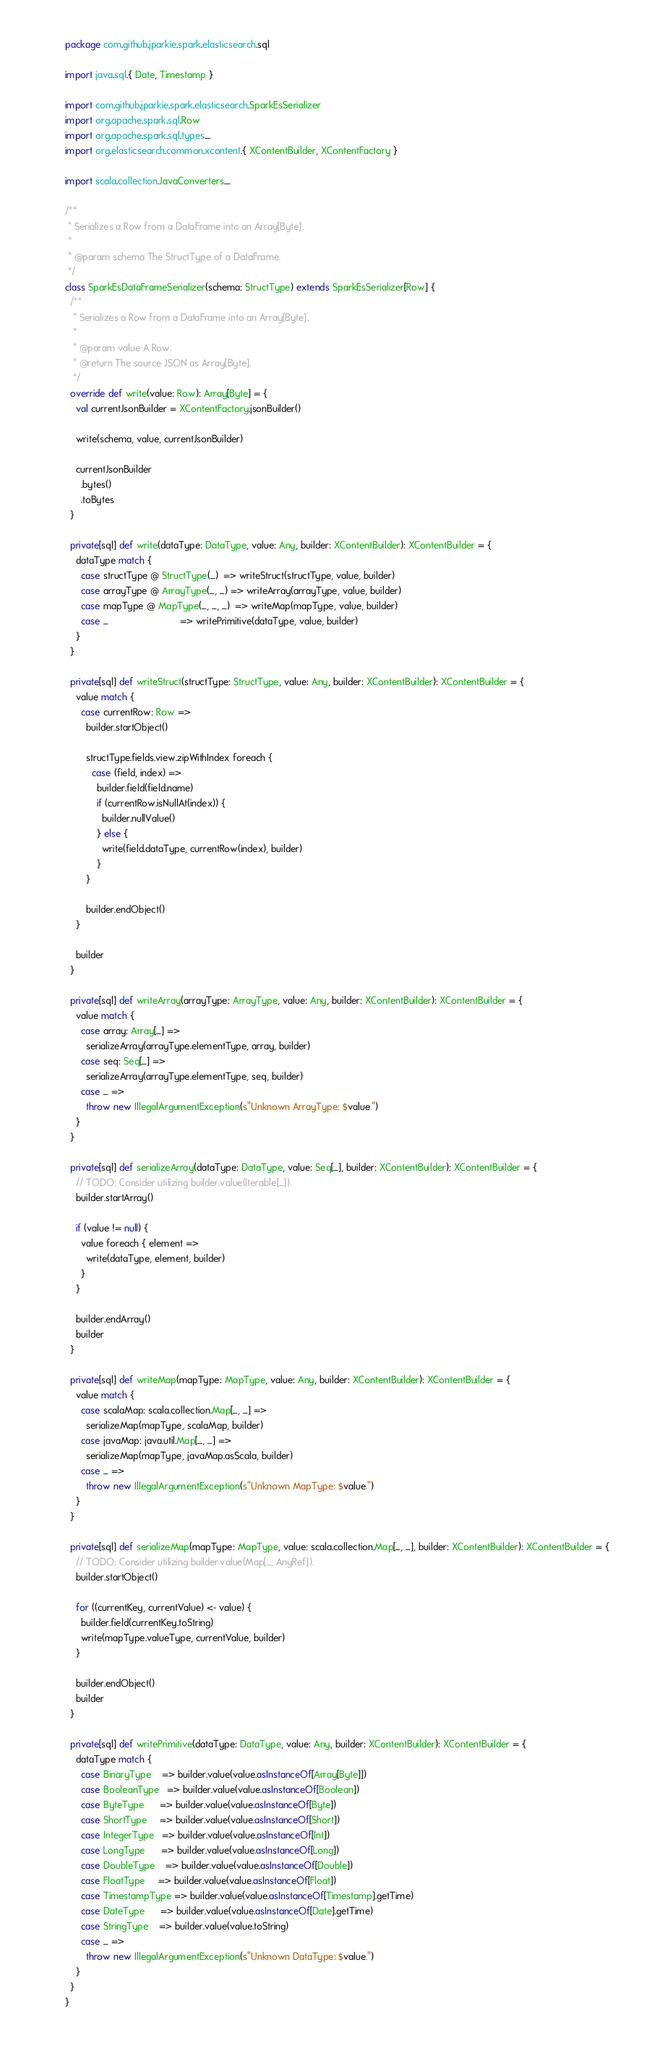Convert code to text. <code><loc_0><loc_0><loc_500><loc_500><_Scala_>package com.github.jparkie.spark.elasticsearch.sql

import java.sql.{ Date, Timestamp }

import com.github.jparkie.spark.elasticsearch.SparkEsSerializer
import org.apache.spark.sql.Row
import org.apache.spark.sql.types._
import org.elasticsearch.common.xcontent.{ XContentBuilder, XContentFactory }

import scala.collection.JavaConverters._

/**
 * Serializes a Row from a DataFrame into an Array[Byte].
 *
 * @param schema The StructType of a DataFrame.
 */
class SparkEsDataFrameSerializer(schema: StructType) extends SparkEsSerializer[Row] {
  /**
   * Serializes a Row from a DataFrame into an Array[Byte].
   *
   * @param value A Row.
   * @return The source JSON as Array[Byte].
   */
  override def write(value: Row): Array[Byte] = {
    val currentJsonBuilder = XContentFactory.jsonBuilder()

    write(schema, value, currentJsonBuilder)

    currentJsonBuilder
      .bytes()
      .toBytes
  }

  private[sql] def write(dataType: DataType, value: Any, builder: XContentBuilder): XContentBuilder = {
    dataType match {
      case structType @ StructType(_)  => writeStruct(structType, value, builder)
      case arrayType @ ArrayType(_, _) => writeArray(arrayType, value, builder)
      case mapType @ MapType(_, _, _)  => writeMap(mapType, value, builder)
      case _                           => writePrimitive(dataType, value, builder)
    }
  }

  private[sql] def writeStruct(structType: StructType, value: Any, builder: XContentBuilder): XContentBuilder = {
    value match {
      case currentRow: Row =>
        builder.startObject()

        structType.fields.view.zipWithIndex foreach {
          case (field, index) =>
            builder.field(field.name)
            if (currentRow.isNullAt(index)) {
              builder.nullValue()
            } else {
              write(field.dataType, currentRow(index), builder)
            }
        }

        builder.endObject()
    }

    builder
  }

  private[sql] def writeArray(arrayType: ArrayType, value: Any, builder: XContentBuilder): XContentBuilder = {
    value match {
      case array: Array[_] =>
        serializeArray(arrayType.elementType, array, builder)
      case seq: Seq[_] =>
        serializeArray(arrayType.elementType, seq, builder)
      case _ =>
        throw new IllegalArgumentException(s"Unknown ArrayType: $value.")
    }
  }

  private[sql] def serializeArray(dataType: DataType, value: Seq[_], builder: XContentBuilder): XContentBuilder = {
    // TODO: Consider utilizing builder.value(Iterable[_]).
    builder.startArray()

    if (value != null) {
      value foreach { element =>
        write(dataType, element, builder)
      }
    }

    builder.endArray()
    builder
  }

  private[sql] def writeMap(mapType: MapType, value: Any, builder: XContentBuilder): XContentBuilder = {
    value match {
      case scalaMap: scala.collection.Map[_, _] =>
        serializeMap(mapType, scalaMap, builder)
      case javaMap: java.util.Map[_, _] =>
        serializeMap(mapType, javaMap.asScala, builder)
      case _ =>
        throw new IllegalArgumentException(s"Unknown MapType: $value.")
    }
  }

  private[sql] def serializeMap(mapType: MapType, value: scala.collection.Map[_, _], builder: XContentBuilder): XContentBuilder = {
    // TODO: Consider utilizing builder.value(Map[_, AnyRef]).
    builder.startObject()

    for ((currentKey, currentValue) <- value) {
      builder.field(currentKey.toString)
      write(mapType.valueType, currentValue, builder)
    }

    builder.endObject()
    builder
  }

  private[sql] def writePrimitive(dataType: DataType, value: Any, builder: XContentBuilder): XContentBuilder = {
    dataType match {
      case BinaryType    => builder.value(value.asInstanceOf[Array[Byte]])
      case BooleanType   => builder.value(value.asInstanceOf[Boolean])
      case ByteType      => builder.value(value.asInstanceOf[Byte])
      case ShortType     => builder.value(value.asInstanceOf[Short])
      case IntegerType   => builder.value(value.asInstanceOf[Int])
      case LongType      => builder.value(value.asInstanceOf[Long])
      case DoubleType    => builder.value(value.asInstanceOf[Double])
      case FloatType     => builder.value(value.asInstanceOf[Float])
      case TimestampType => builder.value(value.asInstanceOf[Timestamp].getTime)
      case DateType      => builder.value(value.asInstanceOf[Date].getTime)
      case StringType    => builder.value(value.toString)
      case _ =>
        throw new IllegalArgumentException(s"Unknown DataType: $value.")
    }
  }
}
</code> 